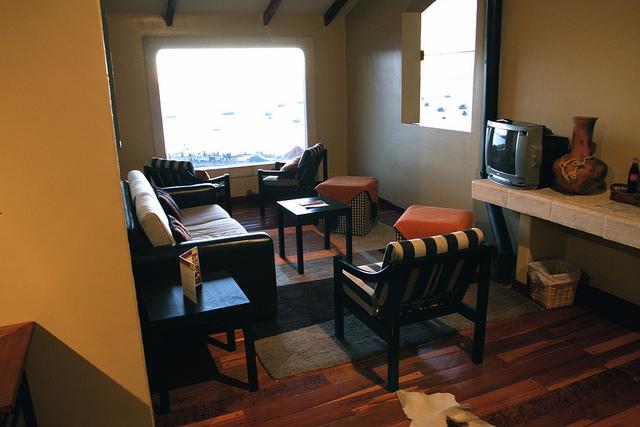What electronic device is in this room?
Give a very brief answer. Tv. Are there stripes in the image?
Give a very brief answer. Yes. How many tables are in the room?
Answer briefly. 3. How many places are there to sit down?
Write a very short answer. 7. 